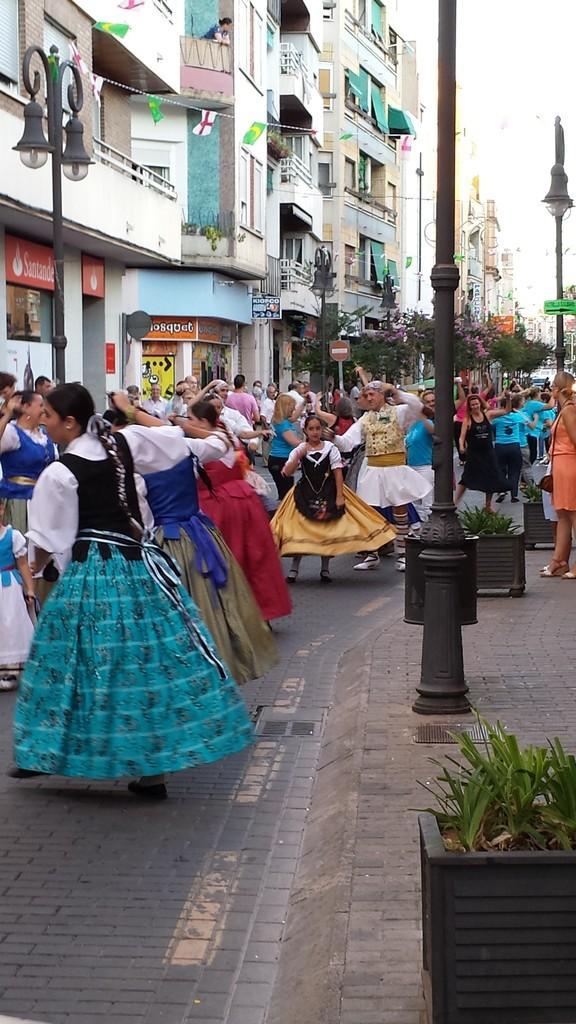In one or two sentences, can you explain what this image depicts? In this image, on the left side, we can see a group of people are dancing. On the right side, we can see a flower pot, plant, pillar, pole, street light, a group of people standing on the footpath. On the left side, we can see some building, street lights, glass window, hoardings. At the top, we can see a sky, at the bottom, we can see a road and a footpath. 